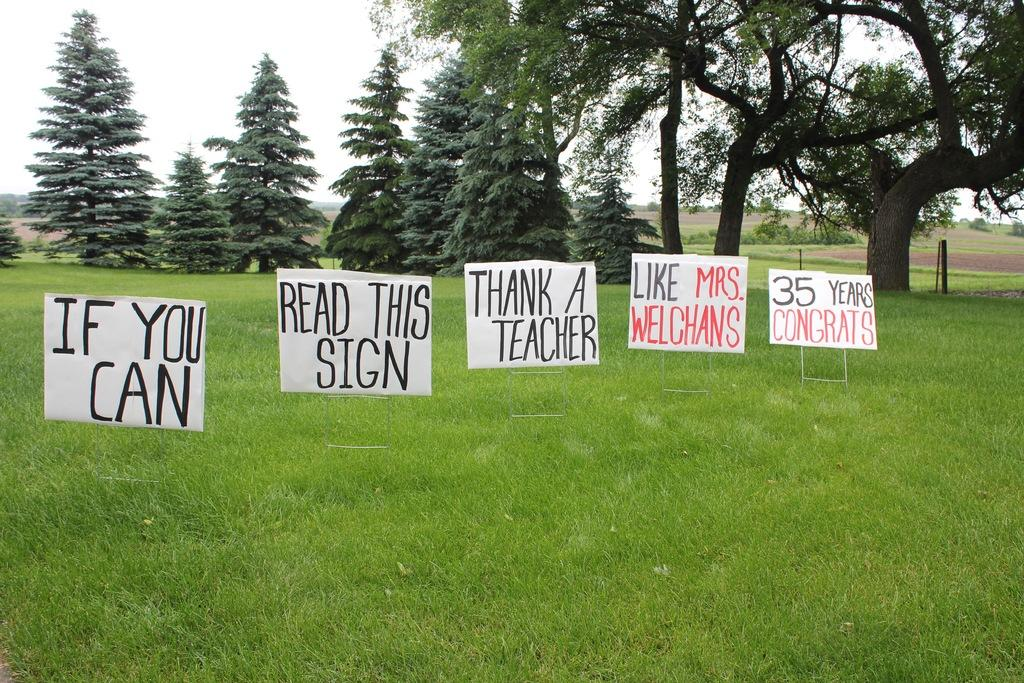What type of ground is visible in the image? There is grass ground in the image. What color are the boards in the image? The boards in the image are white. What can be seen in the background of the image? There are trees in the image. What is written on the boards? There is writing on the boards. What type of paint is used to create the wish on the board? There is no wish present on the board, and therefore, no paint can be associated with it. 